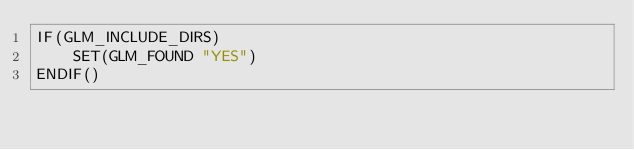Convert code to text. <code><loc_0><loc_0><loc_500><loc_500><_CMake_>IF(GLM_INCLUDE_DIRS)
    SET(GLM_FOUND "YES")
ENDIF()
</code> 